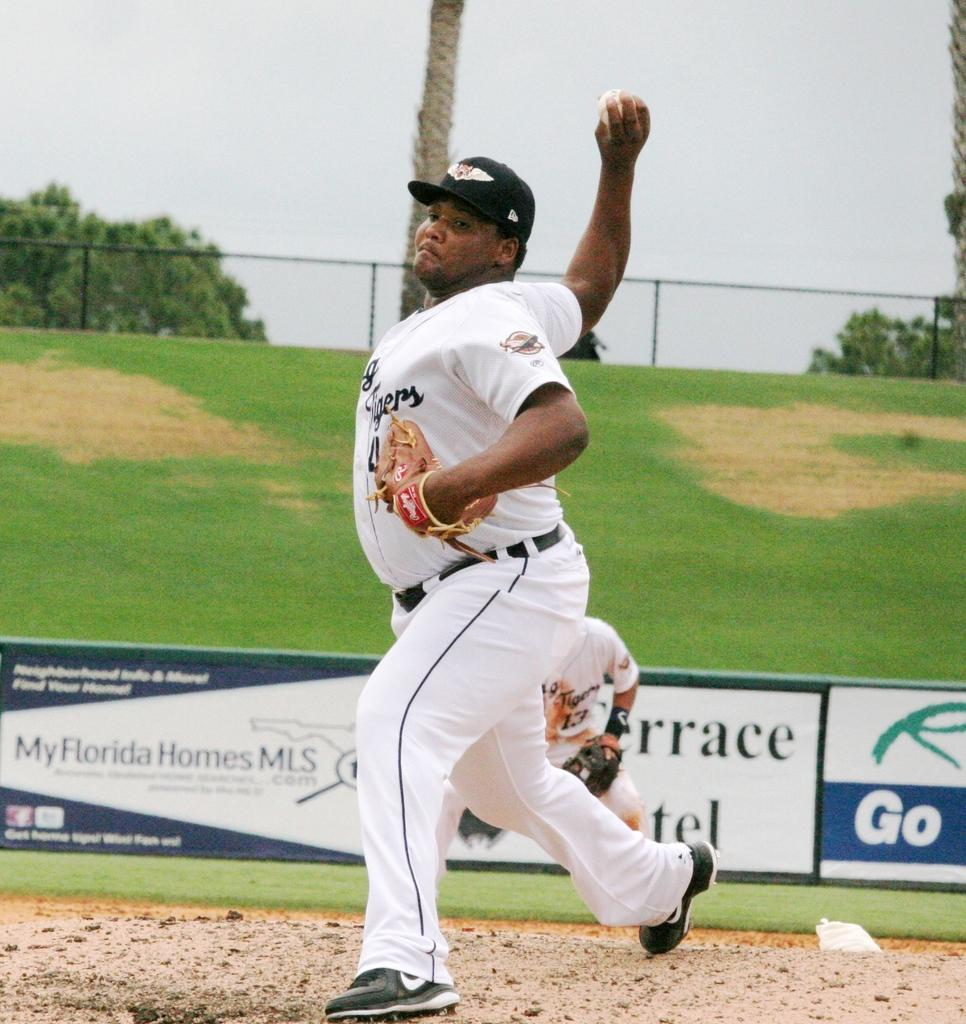<image>
Describe the image concisely. a baseball player throwing ball in front of a My Florida Homes MLS banner 